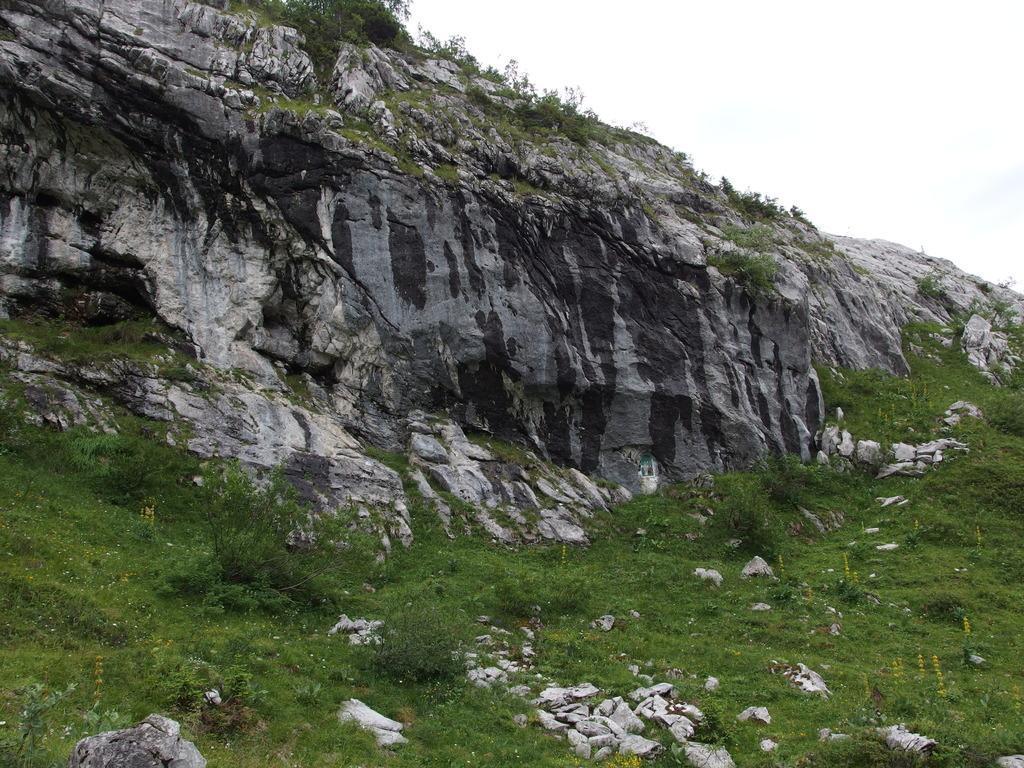Please provide a concise description of this image. In this picture I can observe some grass and plants on the ground. I can observe a hill. In the background there is a sky. 